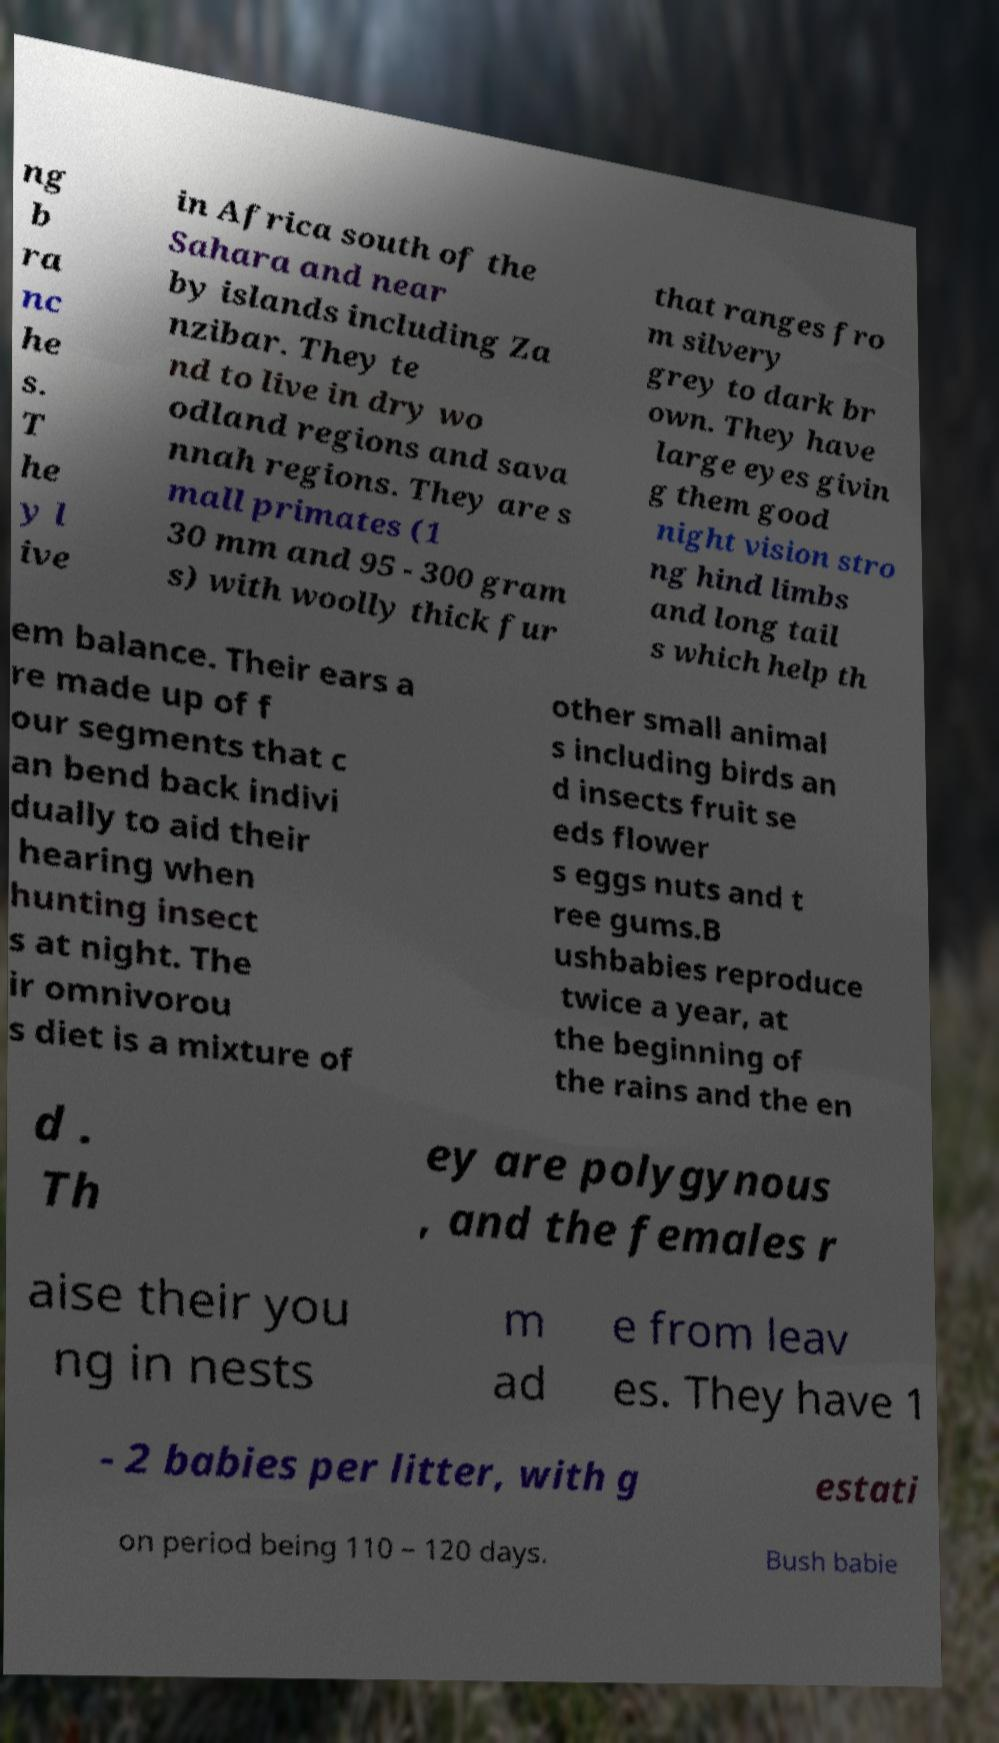Could you assist in decoding the text presented in this image and type it out clearly? ng b ra nc he s. T he y l ive in Africa south of the Sahara and near by islands including Za nzibar. They te nd to live in dry wo odland regions and sava nnah regions. They are s mall primates (1 30 mm and 95 - 300 gram s) with woolly thick fur that ranges fro m silvery grey to dark br own. They have large eyes givin g them good night vision stro ng hind limbs and long tail s which help th em balance. Their ears a re made up of f our segments that c an bend back indivi dually to aid their hearing when hunting insect s at night. The ir omnivorou s diet is a mixture of other small animal s including birds an d insects fruit se eds flower s eggs nuts and t ree gums.B ushbabies reproduce twice a year, at the beginning of the rains and the en d . Th ey are polygynous , and the females r aise their you ng in nests m ad e from leav es. They have 1 - 2 babies per litter, with g estati on period being 110 – 120 days. Bush babie 